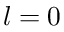Convert formula to latex. <formula><loc_0><loc_0><loc_500><loc_500>l = 0</formula> 